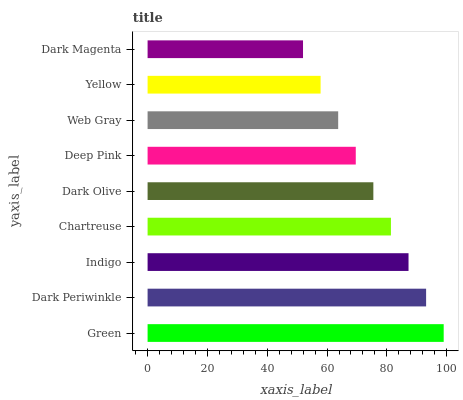Is Dark Magenta the minimum?
Answer yes or no. Yes. Is Green the maximum?
Answer yes or no. Yes. Is Dark Periwinkle the minimum?
Answer yes or no. No. Is Dark Periwinkle the maximum?
Answer yes or no. No. Is Green greater than Dark Periwinkle?
Answer yes or no. Yes. Is Dark Periwinkle less than Green?
Answer yes or no. Yes. Is Dark Periwinkle greater than Green?
Answer yes or no. No. Is Green less than Dark Periwinkle?
Answer yes or no. No. Is Dark Olive the high median?
Answer yes or no. Yes. Is Dark Olive the low median?
Answer yes or no. Yes. Is Web Gray the high median?
Answer yes or no. No. Is Dark Periwinkle the low median?
Answer yes or no. No. 